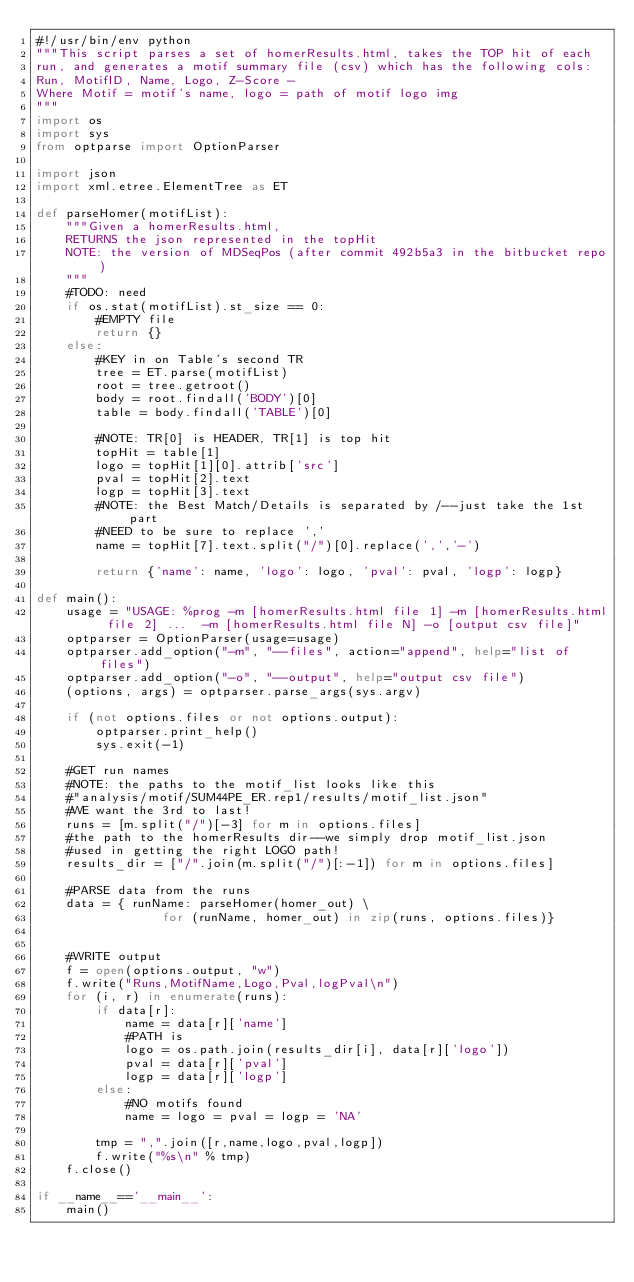Convert code to text. <code><loc_0><loc_0><loc_500><loc_500><_Python_>#!/usr/bin/env python
"""This script parses a set of homerResults.html, takes the TOP hit of each 
run, and generates a motif summary file (csv) which has the following cols:
Run, MotifID, Name, Logo, Z-Score -
Where Motif = motif's name, logo = path of motif logo img
"""
import os
import sys
from optparse import OptionParser

import json
import xml.etree.ElementTree as ET

def parseHomer(motifList):
    """Given a homerResults.html, 
    RETURNS the json represented in the topHit
    NOTE: the version of MDSeqPos (after commit 492b5a3 in the bitbucket repo)
    """
    #TODO: need 
    if os.stat(motifList).st_size == 0:
        #EMPTY file
        return {}
    else:
        #KEY in on Table's second TR
        tree = ET.parse(motifList)
        root = tree.getroot()
        body = root.findall('BODY')[0]
        table = body.findall('TABLE')[0]
        
        #NOTE: TR[0] is HEADER, TR[1] is top hit
        topHit = table[1]
        logo = topHit[1][0].attrib['src']
        pval = topHit[2].text
        logp = topHit[3].text
        #NOTE: the Best Match/Details is separated by /--just take the 1st part
        #NEED to be sure to replace ','
        name = topHit[7].text.split("/")[0].replace(',','-')
        
        return {'name': name, 'logo': logo, 'pval': pval, 'logp': logp}

def main():
    usage = "USAGE: %prog -m [homerResults.html file 1] -m [homerResults.html file 2] ...  -m [homerResults.html file N] -o [output csv file]"
    optparser = OptionParser(usage=usage)
    optparser.add_option("-m", "--files", action="append", help="list of files")
    optparser.add_option("-o", "--output", help="output csv file")
    (options, args) = optparser.parse_args(sys.argv)

    if (not options.files or not options.output):
        optparser.print_help()
        sys.exit(-1)

    #GET run names
    #NOTE: the paths to the motif_list looks like this
    #"analysis/motif/SUM44PE_ER.rep1/results/motif_list.json" 
    #WE want the 3rd to last!
    runs = [m.split("/")[-3] for m in options.files]
    #the path to the homerResults dir--we simply drop motif_list.json
    #used in getting the right LOGO path!
    results_dir = ["/".join(m.split("/")[:-1]) for m in options.files]

    #PARSE data from the runs
    data = { runName: parseHomer(homer_out) \
                 for (runName, homer_out) in zip(runs, options.files)}
    

    #WRITE output 
    f = open(options.output, "w")
    f.write("Runs,MotifName,Logo,Pval,logPval\n")
    for (i, r) in enumerate(runs):
        if data[r]:
            name = data[r]['name']
            #PATH is 
            logo = os.path.join(results_dir[i], data[r]['logo'])
            pval = data[r]['pval']
            logp = data[r]['logp']
        else:
            #NO motifs found
            name = logo = pval = logp = 'NA'

        tmp = ",".join([r,name,logo,pval,logp])
        f.write("%s\n" % tmp)
    f.close()

if __name__=='__main__':
    main()
</code> 